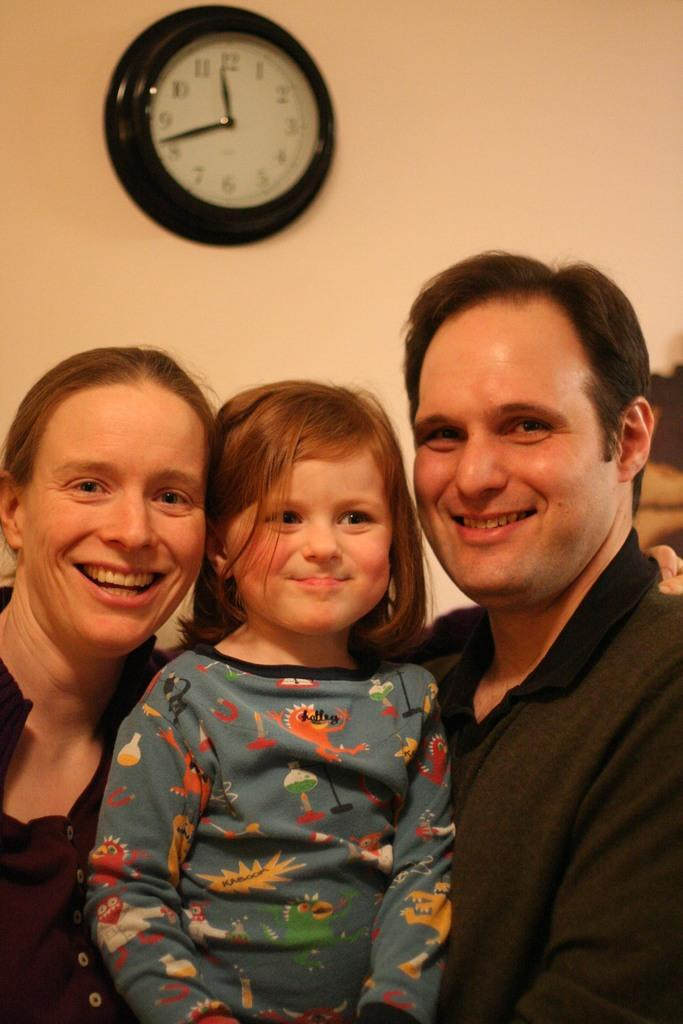<image>
Give a short and clear explanation of the subsequent image. a family of three posing for photo with a wall clock indicating 11:42 